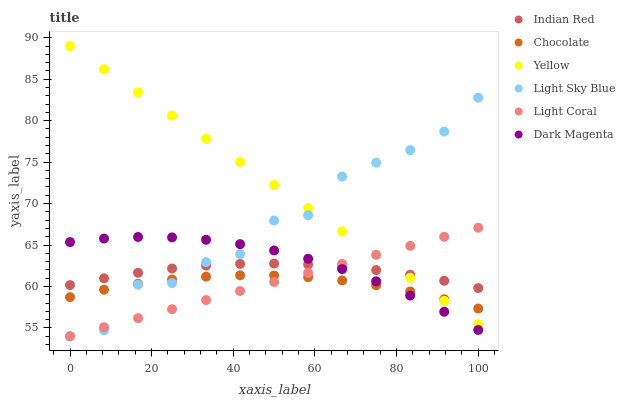Does Chocolate have the minimum area under the curve?
Answer yes or no. Yes. Does Yellow have the maximum area under the curve?
Answer yes or no. Yes. Does Yellow have the minimum area under the curve?
Answer yes or no. No. Does Chocolate have the maximum area under the curve?
Answer yes or no. No. Is Light Coral the smoothest?
Answer yes or no. Yes. Is Light Sky Blue the roughest?
Answer yes or no. Yes. Is Yellow the smoothest?
Answer yes or no. No. Is Yellow the roughest?
Answer yes or no. No. Does Light Coral have the lowest value?
Answer yes or no. Yes. Does Yellow have the lowest value?
Answer yes or no. No. Does Yellow have the highest value?
Answer yes or no. Yes. Does Chocolate have the highest value?
Answer yes or no. No. Is Chocolate less than Indian Red?
Answer yes or no. Yes. Is Indian Red greater than Chocolate?
Answer yes or no. Yes. Does Indian Red intersect Light Coral?
Answer yes or no. Yes. Is Indian Red less than Light Coral?
Answer yes or no. No. Is Indian Red greater than Light Coral?
Answer yes or no. No. Does Chocolate intersect Indian Red?
Answer yes or no. No. 